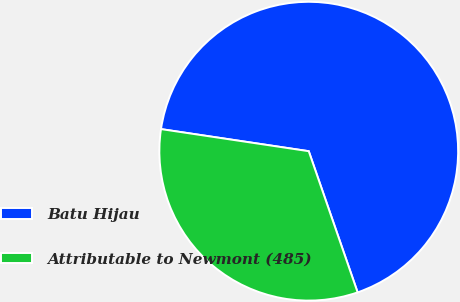<chart> <loc_0><loc_0><loc_500><loc_500><pie_chart><fcel>Batu Hijau<fcel>Attributable to Newmont (485)<nl><fcel>67.33%<fcel>32.67%<nl></chart> 